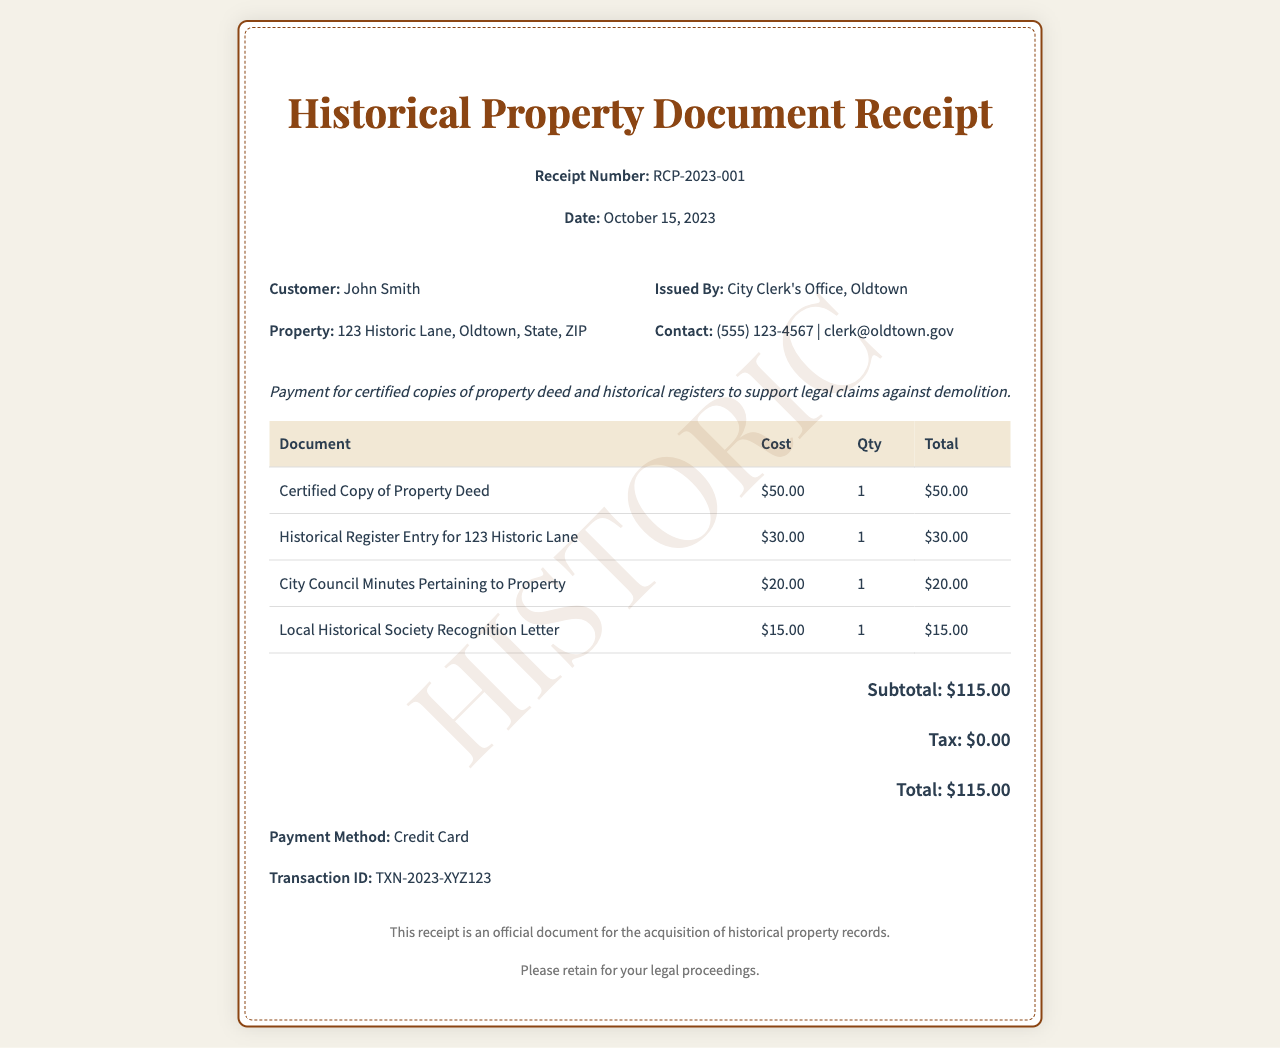What is the receipt number? The receipt number is listed near the top of the document, showing the specific transaction's identification.
Answer: RCP-2023-001 What is the payment total? The total amount charged for the certified copies and related documents is calculated at the bottom of the receipt.
Answer: $115.00 Who issued the receipt? The name of the issuing authority is included in the header section of the document.
Answer: City Clerk's Office, Oldtown What is the date of the receipt? The receipt date is provided near the top of the document, indicating when the payment was processed.
Answer: October 15, 2023 How many certified copies of the property deed were requested? The quantity of each document type is listed in the table specifying the requested items.
Answer: 1 What was the cost of the Historical Register Entry for 123 Historic Lane? The cost details for each document are presented within the pricing table in the receipt.
Answer: $30.00 Which payment method was used? The payment method is explicitly mentioned under the total section of the receipt.
Answer: Credit Card What type of document does this receipt represent? The title at the top of the receipt indicates the nature of the document being a record of payment for historical property documents.
Answer: Historical Property Document Receipt What is the transaction ID? The transaction ID is provided near the payment method, which serves as an additional reference for the transaction.
Answer: TXN-2023-XYZ123 